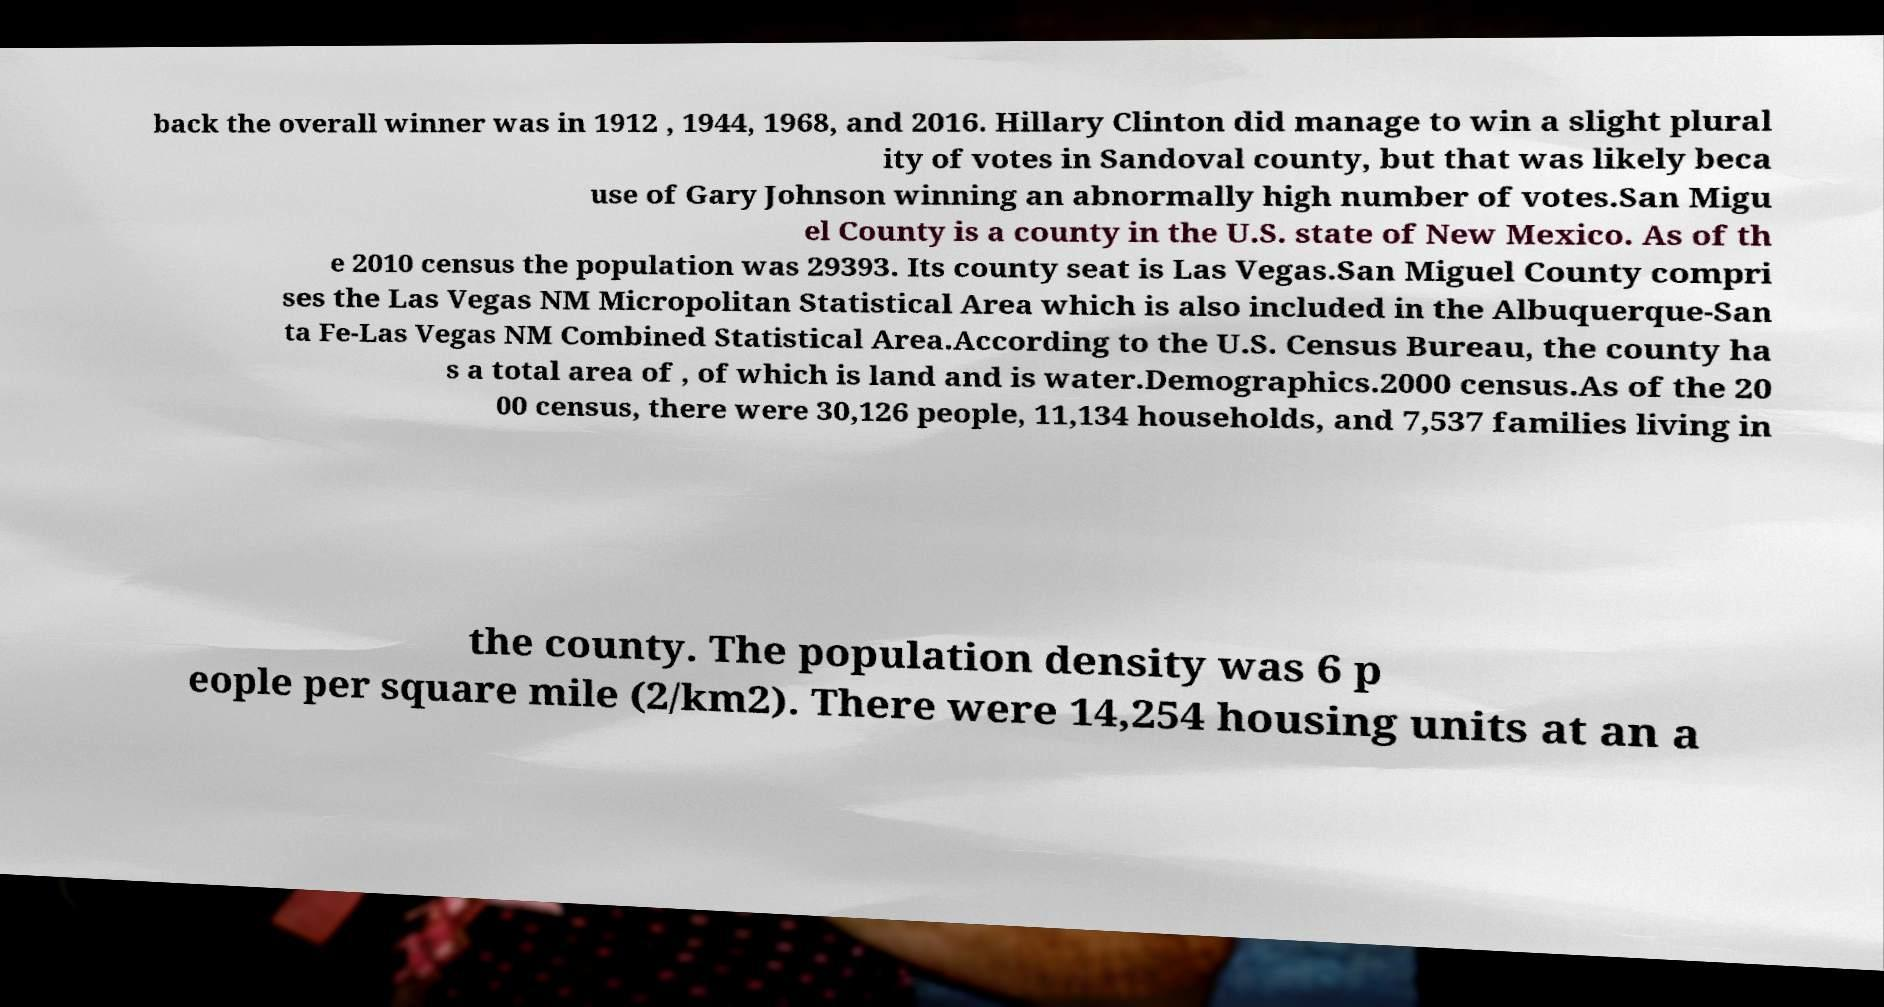Can you accurately transcribe the text from the provided image for me? back the overall winner was in 1912 , 1944, 1968, and 2016. Hillary Clinton did manage to win a slight plural ity of votes in Sandoval county, but that was likely beca use of Gary Johnson winning an abnormally high number of votes.San Migu el County is a county in the U.S. state of New Mexico. As of th e 2010 census the population was 29393. Its county seat is Las Vegas.San Miguel County compri ses the Las Vegas NM Micropolitan Statistical Area which is also included in the Albuquerque-San ta Fe-Las Vegas NM Combined Statistical Area.According to the U.S. Census Bureau, the county ha s a total area of , of which is land and is water.Demographics.2000 census.As of the 20 00 census, there were 30,126 people, 11,134 households, and 7,537 families living in the county. The population density was 6 p eople per square mile (2/km2). There were 14,254 housing units at an a 